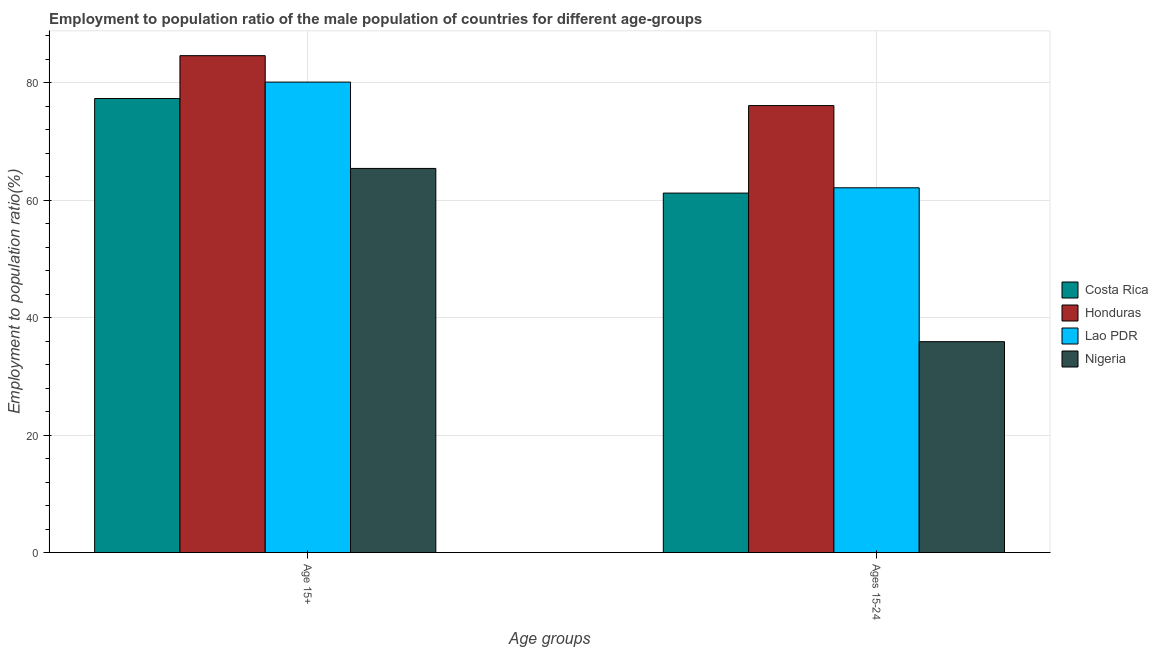Are the number of bars per tick equal to the number of legend labels?
Make the answer very short. Yes. How many bars are there on the 1st tick from the right?
Ensure brevity in your answer.  4. What is the label of the 2nd group of bars from the left?
Provide a succinct answer. Ages 15-24. What is the employment to population ratio(age 15+) in Costa Rica?
Offer a terse response. 77.3. Across all countries, what is the maximum employment to population ratio(age 15+)?
Your answer should be very brief. 84.6. Across all countries, what is the minimum employment to population ratio(age 15+)?
Provide a succinct answer. 65.4. In which country was the employment to population ratio(age 15-24) maximum?
Your response must be concise. Honduras. In which country was the employment to population ratio(age 15+) minimum?
Give a very brief answer. Nigeria. What is the total employment to population ratio(age 15+) in the graph?
Offer a terse response. 307.4. What is the difference between the employment to population ratio(age 15+) in Costa Rica and that in Honduras?
Provide a short and direct response. -7.3. What is the difference between the employment to population ratio(age 15-24) in Nigeria and the employment to population ratio(age 15+) in Lao PDR?
Keep it short and to the point. -44.2. What is the average employment to population ratio(age 15-24) per country?
Give a very brief answer. 58.82. What is the difference between the employment to population ratio(age 15+) and employment to population ratio(age 15-24) in Nigeria?
Your response must be concise. 29.5. What is the ratio of the employment to population ratio(age 15-24) in Honduras to that in Lao PDR?
Offer a very short reply. 1.23. Is the employment to population ratio(age 15+) in Lao PDR less than that in Nigeria?
Make the answer very short. No. What does the 1st bar from the left in Age 15+ represents?
Offer a very short reply. Costa Rica. How many countries are there in the graph?
Make the answer very short. 4. What is the difference between two consecutive major ticks on the Y-axis?
Offer a terse response. 20. Are the values on the major ticks of Y-axis written in scientific E-notation?
Ensure brevity in your answer.  No. Where does the legend appear in the graph?
Your response must be concise. Center right. How are the legend labels stacked?
Ensure brevity in your answer.  Vertical. What is the title of the graph?
Offer a very short reply. Employment to population ratio of the male population of countries for different age-groups. Does "Congo (Republic)" appear as one of the legend labels in the graph?
Your response must be concise. No. What is the label or title of the X-axis?
Your answer should be compact. Age groups. What is the Employment to population ratio(%) in Costa Rica in Age 15+?
Offer a very short reply. 77.3. What is the Employment to population ratio(%) of Honduras in Age 15+?
Your answer should be very brief. 84.6. What is the Employment to population ratio(%) of Lao PDR in Age 15+?
Provide a short and direct response. 80.1. What is the Employment to population ratio(%) in Nigeria in Age 15+?
Make the answer very short. 65.4. What is the Employment to population ratio(%) in Costa Rica in Ages 15-24?
Give a very brief answer. 61.2. What is the Employment to population ratio(%) in Honduras in Ages 15-24?
Ensure brevity in your answer.  76.1. What is the Employment to population ratio(%) in Lao PDR in Ages 15-24?
Provide a short and direct response. 62.1. What is the Employment to population ratio(%) in Nigeria in Ages 15-24?
Provide a short and direct response. 35.9. Across all Age groups, what is the maximum Employment to population ratio(%) of Costa Rica?
Make the answer very short. 77.3. Across all Age groups, what is the maximum Employment to population ratio(%) of Honduras?
Provide a succinct answer. 84.6. Across all Age groups, what is the maximum Employment to population ratio(%) of Lao PDR?
Keep it short and to the point. 80.1. Across all Age groups, what is the maximum Employment to population ratio(%) in Nigeria?
Give a very brief answer. 65.4. Across all Age groups, what is the minimum Employment to population ratio(%) of Costa Rica?
Offer a terse response. 61.2. Across all Age groups, what is the minimum Employment to population ratio(%) in Honduras?
Your response must be concise. 76.1. Across all Age groups, what is the minimum Employment to population ratio(%) in Lao PDR?
Provide a short and direct response. 62.1. Across all Age groups, what is the minimum Employment to population ratio(%) in Nigeria?
Offer a terse response. 35.9. What is the total Employment to population ratio(%) of Costa Rica in the graph?
Your response must be concise. 138.5. What is the total Employment to population ratio(%) of Honduras in the graph?
Offer a terse response. 160.7. What is the total Employment to population ratio(%) of Lao PDR in the graph?
Ensure brevity in your answer.  142.2. What is the total Employment to population ratio(%) of Nigeria in the graph?
Your answer should be very brief. 101.3. What is the difference between the Employment to population ratio(%) in Nigeria in Age 15+ and that in Ages 15-24?
Provide a succinct answer. 29.5. What is the difference between the Employment to population ratio(%) of Costa Rica in Age 15+ and the Employment to population ratio(%) of Honduras in Ages 15-24?
Offer a very short reply. 1.2. What is the difference between the Employment to population ratio(%) of Costa Rica in Age 15+ and the Employment to population ratio(%) of Lao PDR in Ages 15-24?
Your answer should be very brief. 15.2. What is the difference between the Employment to population ratio(%) in Costa Rica in Age 15+ and the Employment to population ratio(%) in Nigeria in Ages 15-24?
Keep it short and to the point. 41.4. What is the difference between the Employment to population ratio(%) of Honduras in Age 15+ and the Employment to population ratio(%) of Nigeria in Ages 15-24?
Give a very brief answer. 48.7. What is the difference between the Employment to population ratio(%) in Lao PDR in Age 15+ and the Employment to population ratio(%) in Nigeria in Ages 15-24?
Your answer should be compact. 44.2. What is the average Employment to population ratio(%) of Costa Rica per Age groups?
Give a very brief answer. 69.25. What is the average Employment to population ratio(%) in Honduras per Age groups?
Provide a succinct answer. 80.35. What is the average Employment to population ratio(%) of Lao PDR per Age groups?
Provide a succinct answer. 71.1. What is the average Employment to population ratio(%) in Nigeria per Age groups?
Provide a short and direct response. 50.65. What is the difference between the Employment to population ratio(%) of Honduras and Employment to population ratio(%) of Nigeria in Age 15+?
Offer a terse response. 19.2. What is the difference between the Employment to population ratio(%) of Costa Rica and Employment to population ratio(%) of Honduras in Ages 15-24?
Make the answer very short. -14.9. What is the difference between the Employment to population ratio(%) of Costa Rica and Employment to population ratio(%) of Lao PDR in Ages 15-24?
Give a very brief answer. -0.9. What is the difference between the Employment to population ratio(%) of Costa Rica and Employment to population ratio(%) of Nigeria in Ages 15-24?
Your answer should be very brief. 25.3. What is the difference between the Employment to population ratio(%) of Honduras and Employment to population ratio(%) of Lao PDR in Ages 15-24?
Provide a succinct answer. 14. What is the difference between the Employment to population ratio(%) of Honduras and Employment to population ratio(%) of Nigeria in Ages 15-24?
Give a very brief answer. 40.2. What is the difference between the Employment to population ratio(%) of Lao PDR and Employment to population ratio(%) of Nigeria in Ages 15-24?
Offer a terse response. 26.2. What is the ratio of the Employment to population ratio(%) in Costa Rica in Age 15+ to that in Ages 15-24?
Provide a succinct answer. 1.26. What is the ratio of the Employment to population ratio(%) in Honduras in Age 15+ to that in Ages 15-24?
Give a very brief answer. 1.11. What is the ratio of the Employment to population ratio(%) in Lao PDR in Age 15+ to that in Ages 15-24?
Provide a short and direct response. 1.29. What is the ratio of the Employment to population ratio(%) of Nigeria in Age 15+ to that in Ages 15-24?
Keep it short and to the point. 1.82. What is the difference between the highest and the second highest Employment to population ratio(%) in Nigeria?
Offer a very short reply. 29.5. What is the difference between the highest and the lowest Employment to population ratio(%) in Honduras?
Your answer should be compact. 8.5. What is the difference between the highest and the lowest Employment to population ratio(%) of Nigeria?
Offer a terse response. 29.5. 